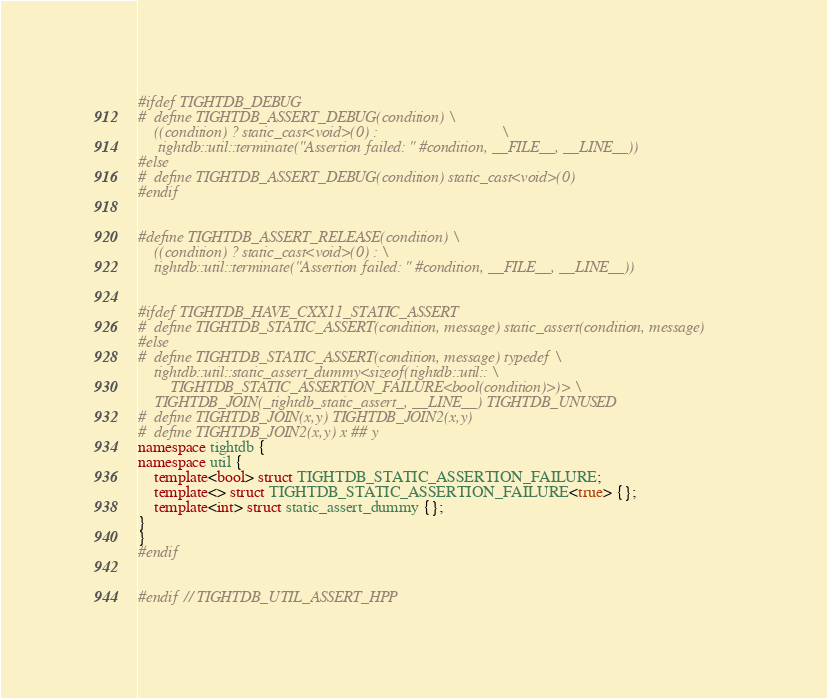Convert code to text. <code><loc_0><loc_0><loc_500><loc_500><_C++_>#ifdef TIGHTDB_DEBUG
#  define TIGHTDB_ASSERT_DEBUG(condition) \
    ((condition) ? static_cast<void>(0) :                               \
     tightdb::util::terminate("Assertion failed: " #condition, __FILE__, __LINE__))
#else
#  define TIGHTDB_ASSERT_DEBUG(condition) static_cast<void>(0)
#endif


#define TIGHTDB_ASSERT_RELEASE(condition) \
    ((condition) ? static_cast<void>(0) : \
    tightdb::util::terminate("Assertion failed: " #condition, __FILE__, __LINE__))


#ifdef TIGHTDB_HAVE_CXX11_STATIC_ASSERT
#  define TIGHTDB_STATIC_ASSERT(condition, message) static_assert(condition, message)
#else
#  define TIGHTDB_STATIC_ASSERT(condition, message) typedef \
    tightdb::util::static_assert_dummy<sizeof(tightdb::util:: \
        TIGHTDB_STATIC_ASSERTION_FAILURE<bool(condition)>)> \
    TIGHTDB_JOIN(_tightdb_static_assert_, __LINE__) TIGHTDB_UNUSED
#  define TIGHTDB_JOIN(x,y) TIGHTDB_JOIN2(x,y)
#  define TIGHTDB_JOIN2(x,y) x ## y
namespace tightdb {
namespace util {
    template<bool> struct TIGHTDB_STATIC_ASSERTION_FAILURE;
    template<> struct TIGHTDB_STATIC_ASSERTION_FAILURE<true> {};
    template<int> struct static_assert_dummy {};
}
}
#endif


#endif // TIGHTDB_UTIL_ASSERT_HPP
</code> 